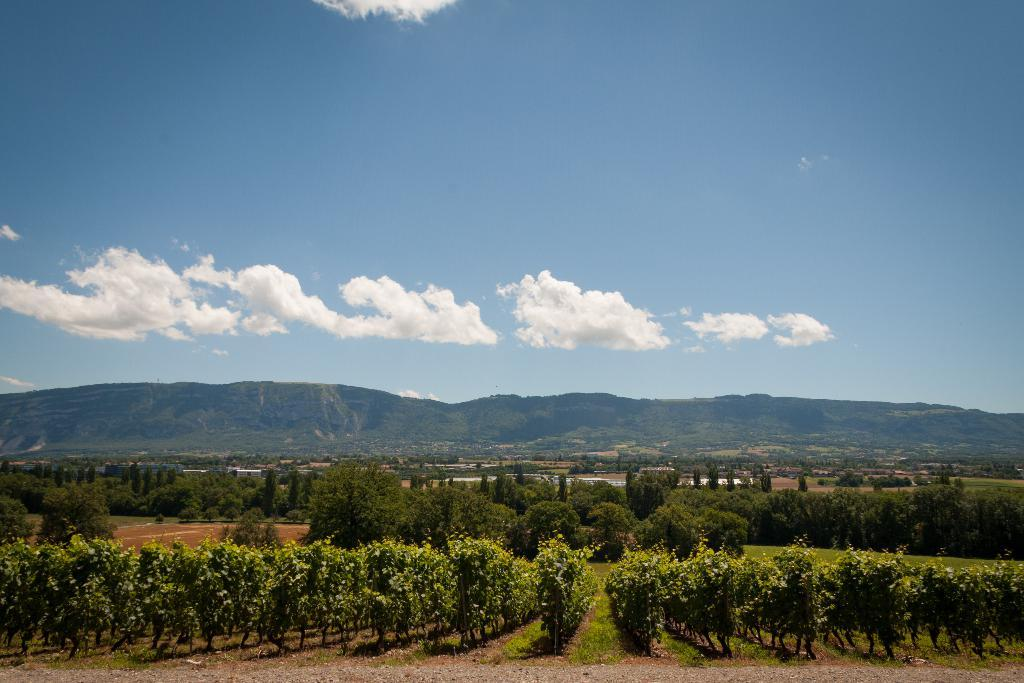What type of vegetation can be seen in the image? There is a group of trees and plants visible in the image. What type of ground cover is present in the image? There is grass visible in the image. What can be seen in the background of the image? There are hills in the background of the image. How would you describe the sky in the image? The sky is visible in the image, and it appears cloudy. What type of glue is being used to hold the clouds together in the image? There is no glue present in the image, and the clouds are not being held together by any substance. 